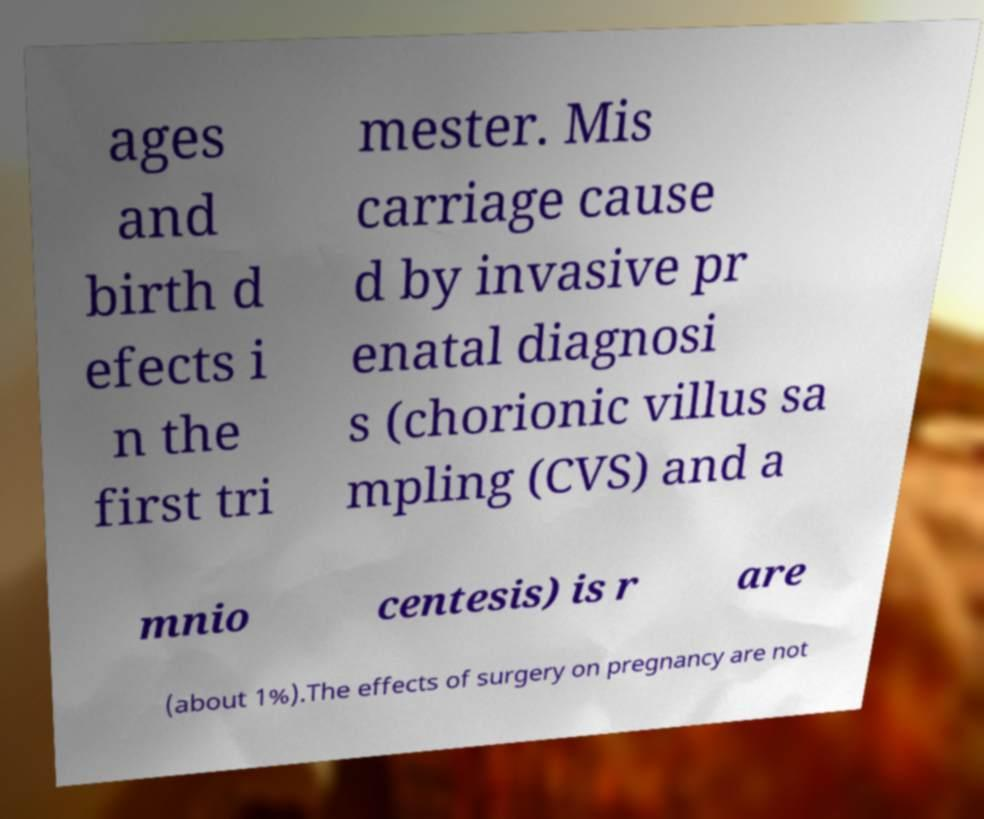For documentation purposes, I need the text within this image transcribed. Could you provide that? ages and birth d efects i n the first tri mester. Mis carriage cause d by invasive pr enatal diagnosi s (chorionic villus sa mpling (CVS) and a mnio centesis) is r are (about 1%).The effects of surgery on pregnancy are not 